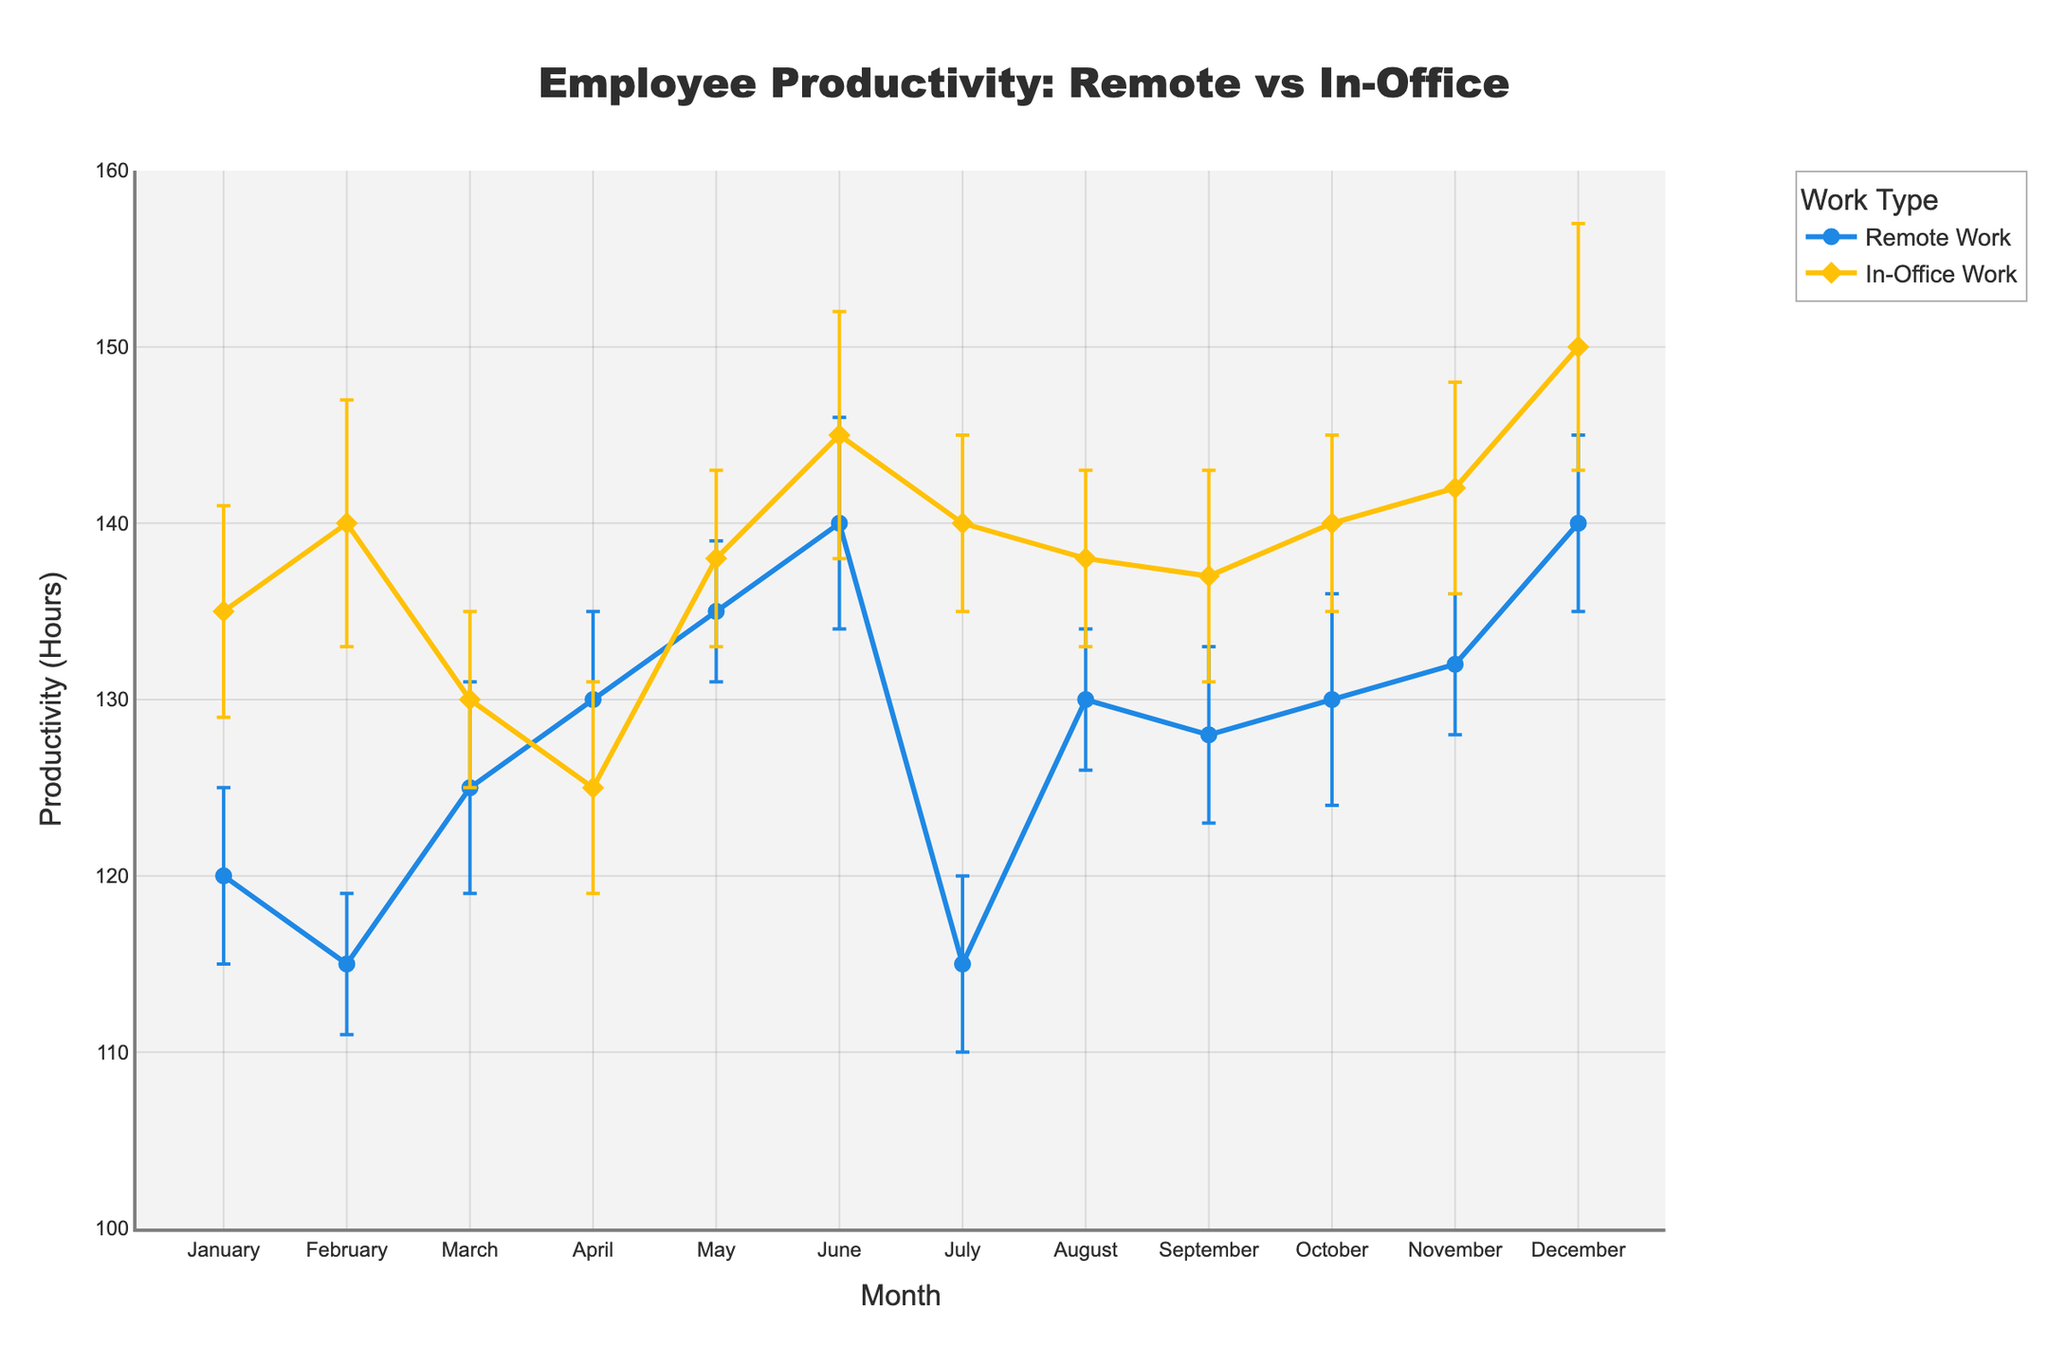What is the title of the plot? The title of the plot is written at the top of the figure. It says, "Employee Productivity: Remote vs In-Office".
Answer: Employee Productivity: Remote vs In-Office Which month had the highest remote productivity? To find the highest remote productivity, look at the y-axis values for "Remote Work" across all months and identify the peak. December shows 140 hours, which is the highest.
Answer: December What is the range of productivity (hours) represented on the y-axis? The y-axis ranges from 100 hours to 160 hours, as shown by the axis ticks and labels.
Answer: 100 to 160 hours Which month shows the greatest difference in productivity between remote and in-office work? By comparing the productivity values for each month, we calculate the difference. December shows remote productivity at 140 hours and in-office at 150 hours, a difference of 10 hours, which is the largest.
Answer: December What is the average in-office productivity over the year? Sum the monthly in-office productivity values and divide by 12 (the number of months): (135 + 140 + 130 + 125 + 138 + 145 + 140 + 138 + 137 + 140 + 142 + 150) / 12 = 1600 / 12 ≈ 133.33.
Answer: 133.33 hours During which months is remote productivity lower than in-office productivity? Compare the productivity values for each month. Remote productivity is lower in January, February, March, July, October, November, and December.
Answer: January, February, March, July, October, November, December What is the error margin for in-office productivity in June? The error margin is visually indicated by the length of the error bars. For June, the in-office productivity error margin is recorded as 7 hours.
Answer: 7 hours How does remote productivity in July compare to in-office productivity in July? July shows remote productivity of 115 hours and in-office productivity of 140 hours; thus, in-office productivity is higher by 25 hours.
Answer: In-office is higher by 25 hours Are there any months where remote productivity consistently increased compared to the previous month? Review the remote productivity trend line month-by-month to check for consistent increases. From February to May and May to June show consecutive increases.
Answer: February to May and May to June What is the combined productivity for both remote and in-office work in May? Add the productivity values for May for both remote and in-office: Remote (135 hours) + In-Office (138 hours) = 273 hours.
Answer: 273 hours 